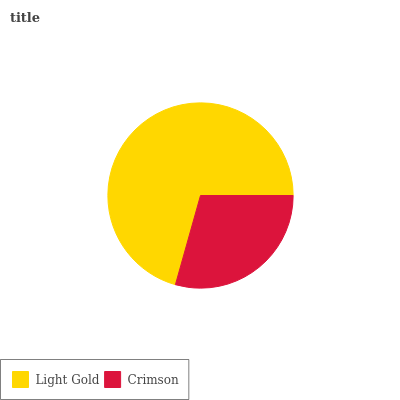Is Crimson the minimum?
Answer yes or no. Yes. Is Light Gold the maximum?
Answer yes or no. Yes. Is Crimson the maximum?
Answer yes or no. No. Is Light Gold greater than Crimson?
Answer yes or no. Yes. Is Crimson less than Light Gold?
Answer yes or no. Yes. Is Crimson greater than Light Gold?
Answer yes or no. No. Is Light Gold less than Crimson?
Answer yes or no. No. Is Light Gold the high median?
Answer yes or no. Yes. Is Crimson the low median?
Answer yes or no. Yes. Is Crimson the high median?
Answer yes or no. No. Is Light Gold the low median?
Answer yes or no. No. 